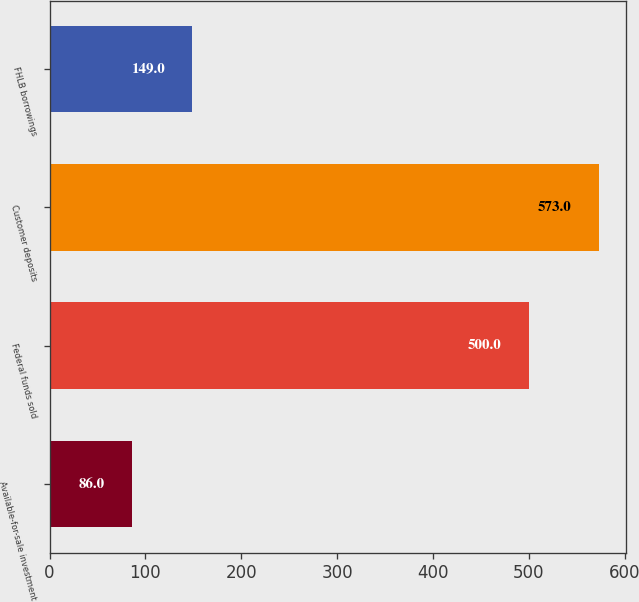<chart> <loc_0><loc_0><loc_500><loc_500><bar_chart><fcel>Available-for-sale investment<fcel>Federal funds sold<fcel>Customer deposits<fcel>FHLB borrowings<nl><fcel>86<fcel>500<fcel>573<fcel>149<nl></chart> 